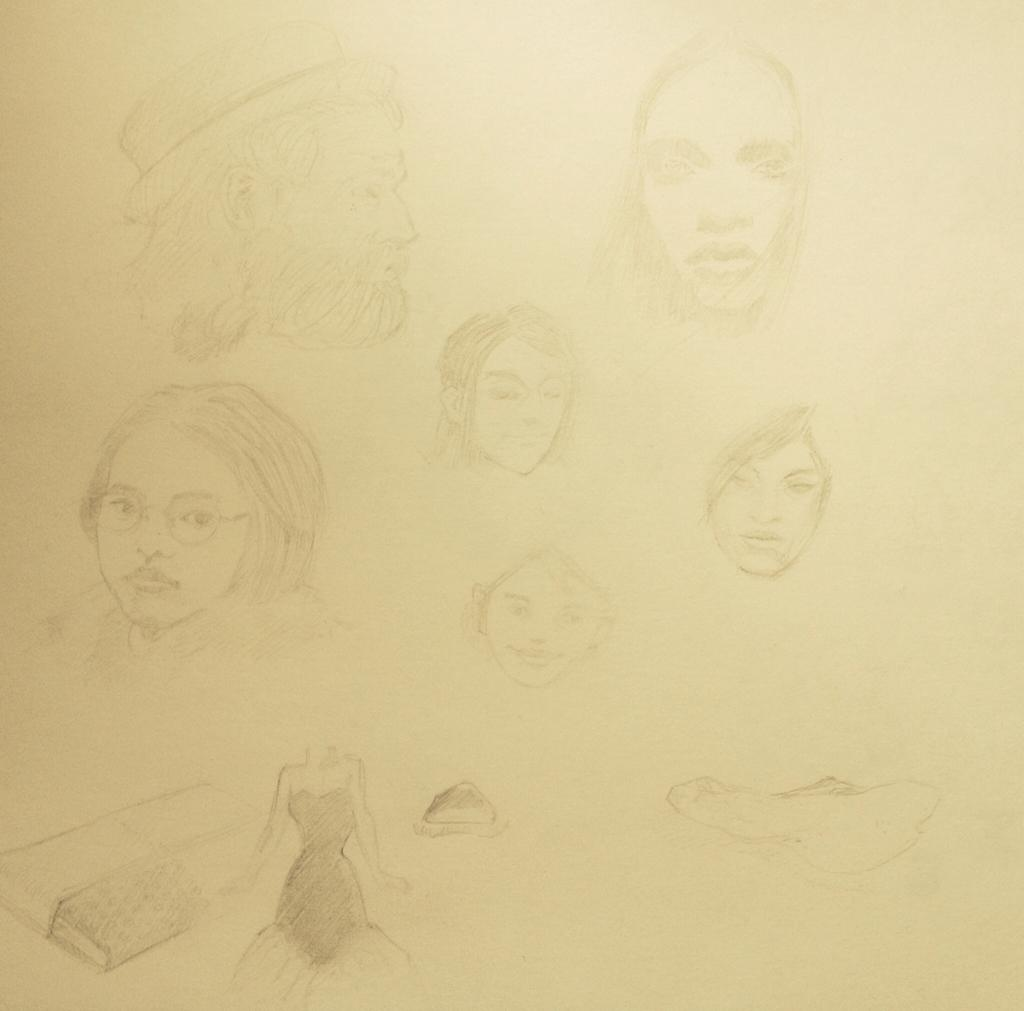What is depicted in the image? There is a drawing in the image. What elements are included in the drawing? The drawing includes persons' faces and objects. Where is the drawing located? The drawing is on a platform. What type of letters are being tested in the drawing? There are no letters or testing being depicted in the drawing; it only includes persons' faces and objects. 